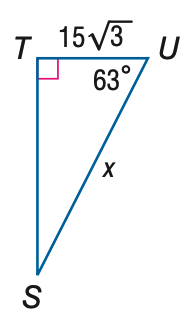Answer the mathemtical geometry problem and directly provide the correct option letter.
Question: Find x. Round to the nearest tenth.
Choices: A: 11.8 B: 29.2 C: 51.0 D: 57.2 D 